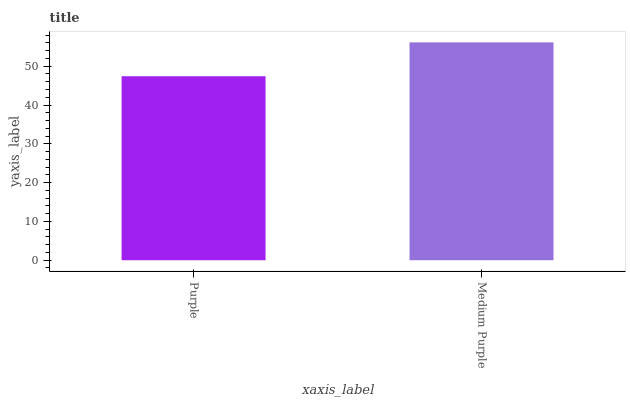Is Purple the minimum?
Answer yes or no. Yes. Is Medium Purple the maximum?
Answer yes or no. Yes. Is Medium Purple the minimum?
Answer yes or no. No. Is Medium Purple greater than Purple?
Answer yes or no. Yes. Is Purple less than Medium Purple?
Answer yes or no. Yes. Is Purple greater than Medium Purple?
Answer yes or no. No. Is Medium Purple less than Purple?
Answer yes or no. No. Is Medium Purple the high median?
Answer yes or no. Yes. Is Purple the low median?
Answer yes or no. Yes. Is Purple the high median?
Answer yes or no. No. Is Medium Purple the low median?
Answer yes or no. No. 